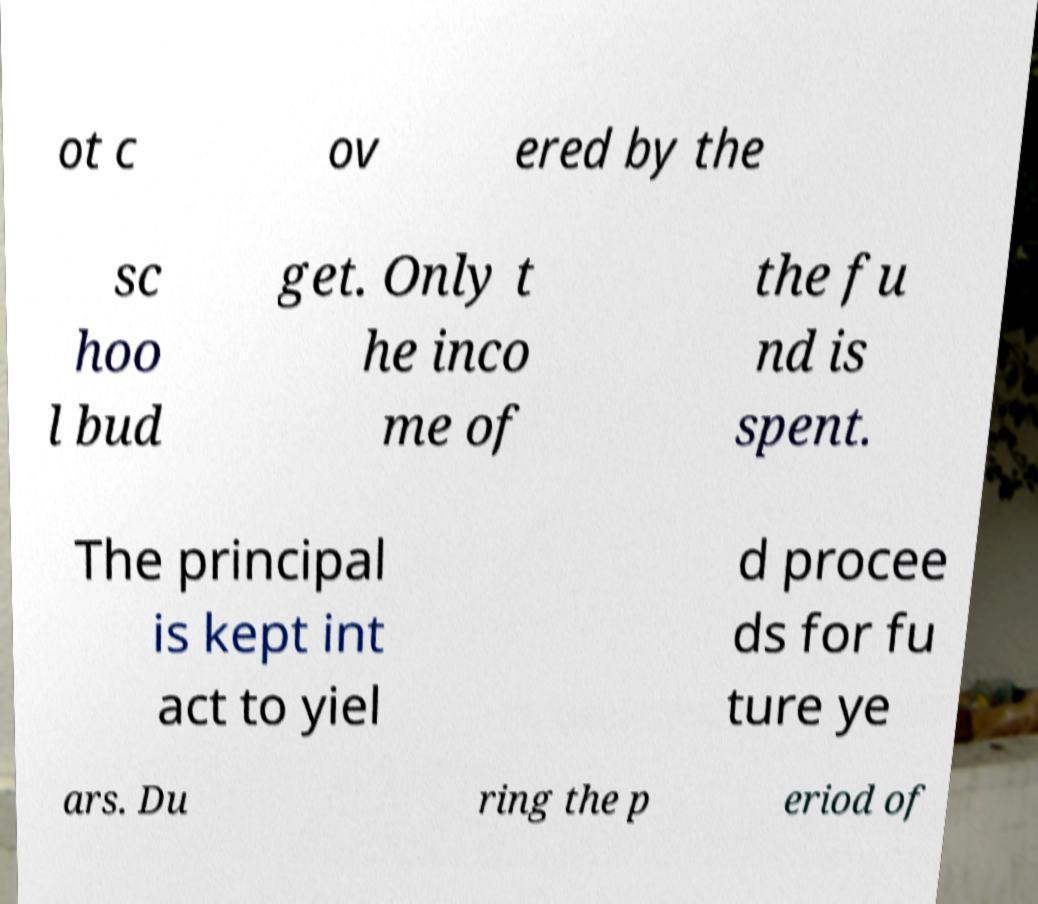Could you assist in decoding the text presented in this image and type it out clearly? ot c ov ered by the sc hoo l bud get. Only t he inco me of the fu nd is spent. The principal is kept int act to yiel d procee ds for fu ture ye ars. Du ring the p eriod of 